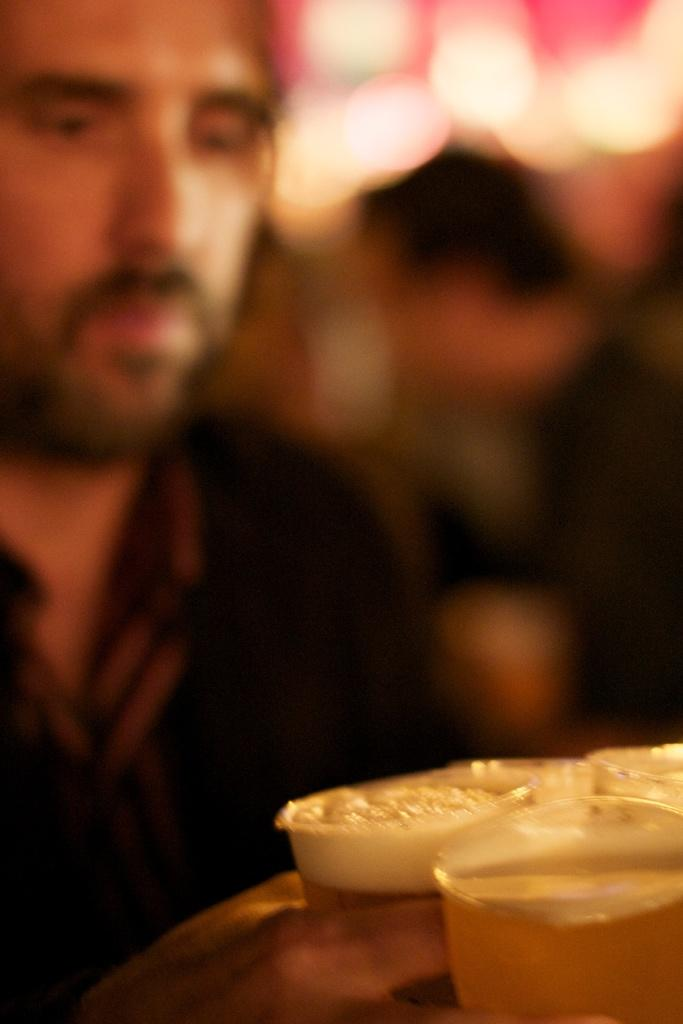What is the main subject of the image? There is a person in the image. What is the person holding in the image? The person is holding glasses filled with a drink. Can you describe the background of the person? The background of the person is blurred. What type of cart is the person using to transport the drinks in the image? There is no cart present in the image; the person is holding glasses filled with a drink. 